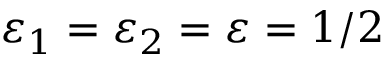Convert formula to latex. <formula><loc_0><loc_0><loc_500><loc_500>\varepsilon _ { 1 } = \varepsilon _ { 2 } = \varepsilon = 1 / 2</formula> 